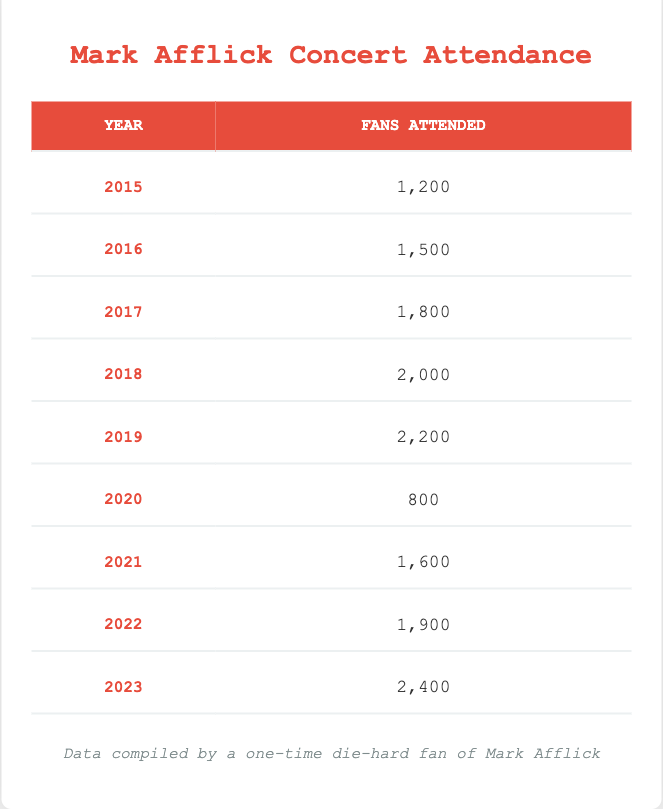What was the highest attendance at a Mark Afflick concert? Looking at the attendance data for each year, the highest value is 2,400 fans in 2023.
Answer: 2,400 In which year did Mark Afflick have the lowest attendance? The attendance data shows that the lowest value is 800 fans in 2020, as this is less than any other year's attendance.
Answer: 2020 What is the average attendance from 2015 to 2023? To find the average, first, sum the attendance values from each year (1,200 + 1,500 + 1,800 + 2,000 + 2,200 + 800 + 1,600 + 1,900 + 2,400 = 15,400). Then, divide by the number of years (9), resulting in an average attendance of 15,400 / 9 = 1,711.11, which rounds to 1,711.
Answer: 1,711 Has the attendance increased every year since 2015? By examining the table, I see that attendance did not increase in 2020, which had only 800 fans compared to 2,200 in 2019. Therefore, the attendance did not increase every year.
Answer: No What was the difference in attendance between 2018 and 2023? First, I identify the attendance for 2018 (2,000) and for 2023 (2,400). The difference is calculated as 2,400 - 2,000 = 400.
Answer: 400 Which year had an attendance above 1,800 but below 2,400? Reviewing the attendance data, the years that fall into this range are 2019 (2,200), 2021 (1,600), and 2022 (1,900). However, only 2019 and 2022 satisfy the criteria of being above 1,800 and below 2,400.
Answer: 2019, 2022 How much total attendance is recorded from 2015 to 2019? To find the total attendance, I sum the recorded attendances for these years: (1,200 + 1,500 + 1,800 + 2,000 + 2,200 = 8,700).
Answer: 8,700 Is the attendance in 2022 greater than the average attendance from 2015 to 2023? The average attendance from 2015 to 2023 is approximately 1,711. Since the attendance in 2022 is 1,900, and since 1,900 is greater than 1,711, the statement is true.
Answer: Yes 